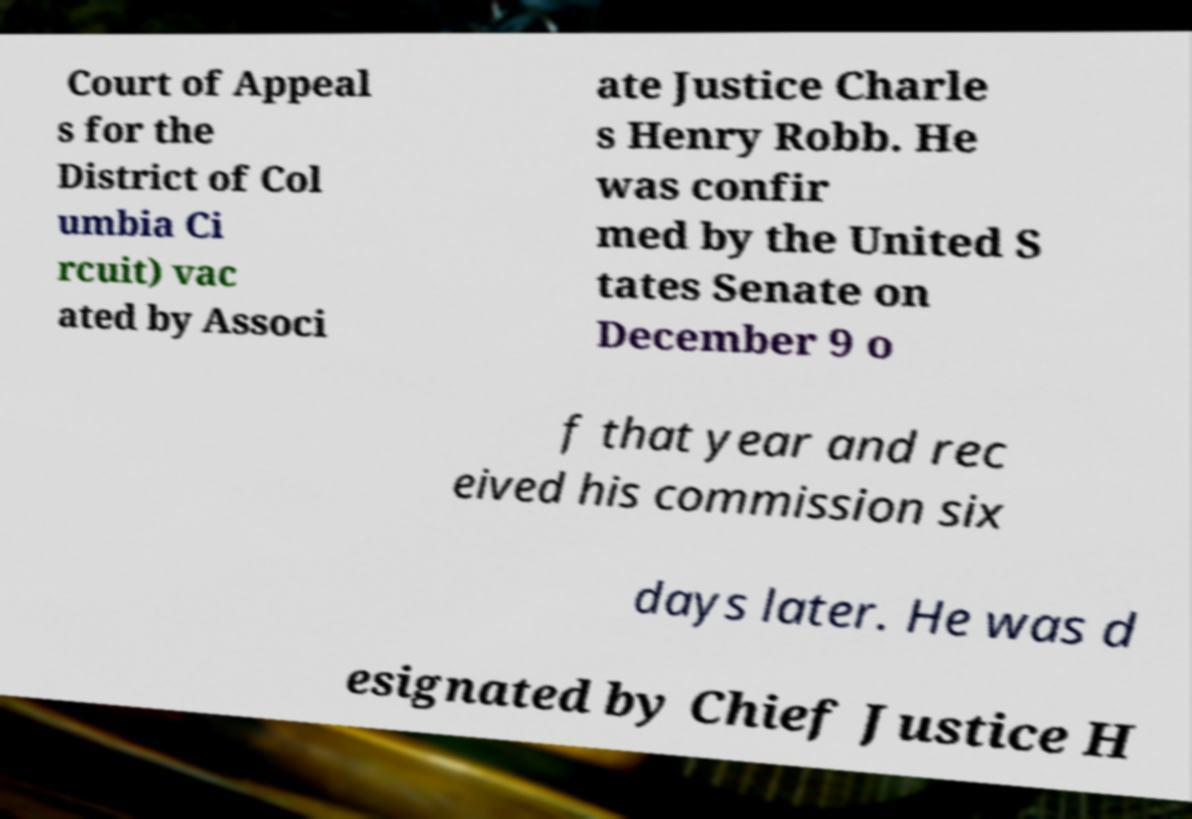Can you accurately transcribe the text from the provided image for me? Court of Appeal s for the District of Col umbia Ci rcuit) vac ated by Associ ate Justice Charle s Henry Robb. He was confir med by the United S tates Senate on December 9 o f that year and rec eived his commission six days later. He was d esignated by Chief Justice H 